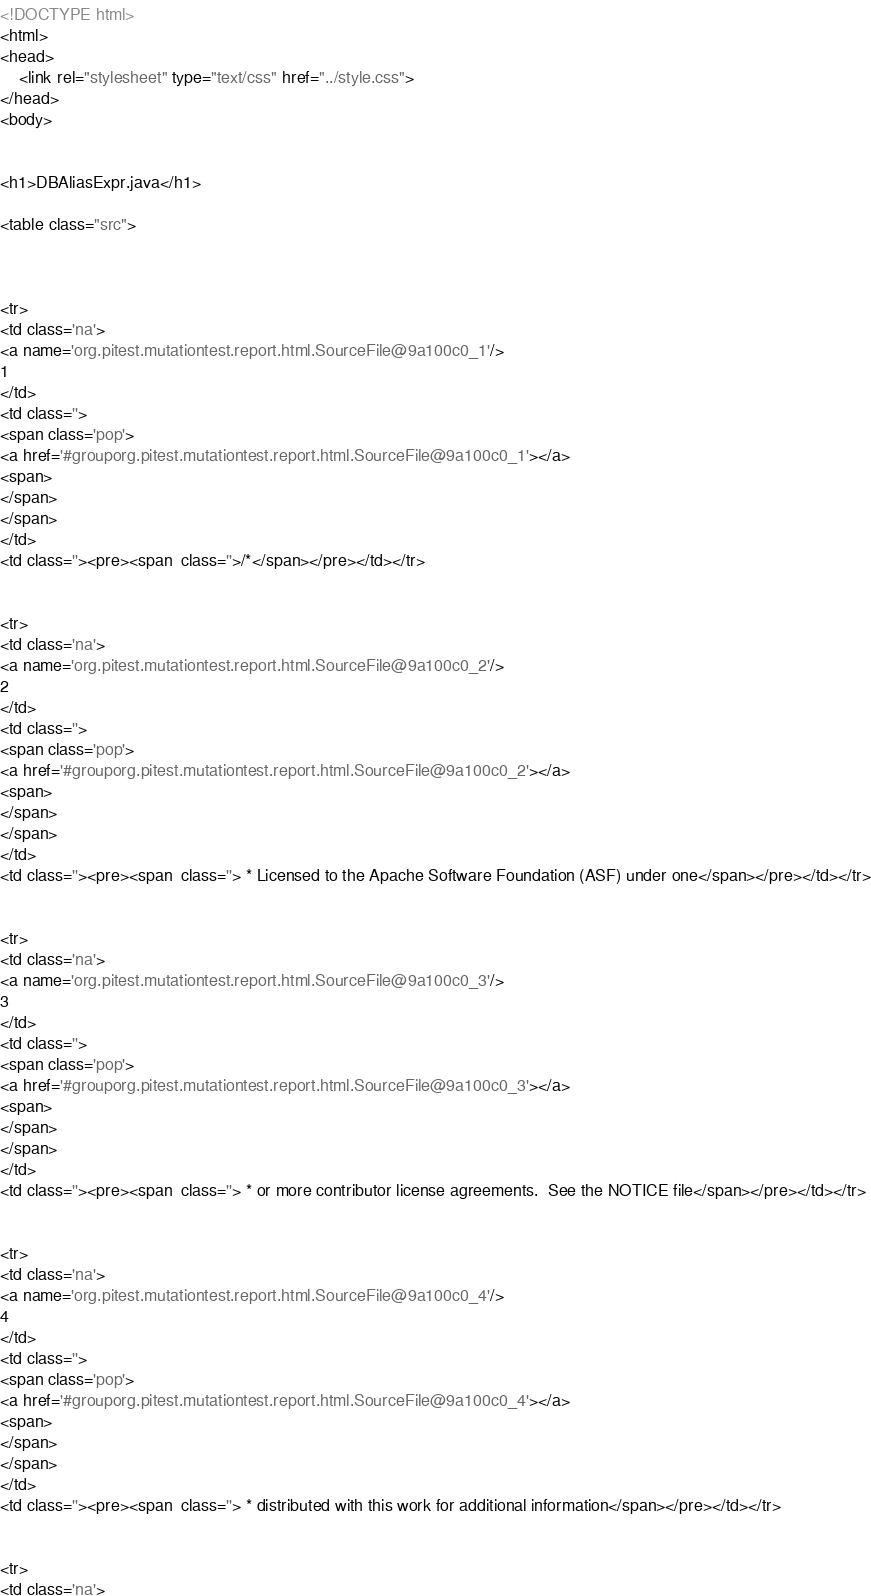Convert code to text. <code><loc_0><loc_0><loc_500><loc_500><_HTML_><!DOCTYPE html>
<html>
<head>
    <link rel="stylesheet" type="text/css" href="../style.css">
</head>
<body>


<h1>DBAliasExpr.java</h1>

<table class="src">



<tr>
<td class='na'>
<a name='org.pitest.mutationtest.report.html.SourceFile@9a100c0_1'/>
1
</td>
<td class=''>
<span class='pop'>
<a href='#grouporg.pitest.mutationtest.report.html.SourceFile@9a100c0_1'></a>
<span>
</span>
</span>
</td>
<td class=''><pre><span  class=''>/*</span></pre></td></tr>


<tr>
<td class='na'>
<a name='org.pitest.mutationtest.report.html.SourceFile@9a100c0_2'/>
2
</td>
<td class=''>
<span class='pop'>
<a href='#grouporg.pitest.mutationtest.report.html.SourceFile@9a100c0_2'></a>
<span>
</span>
</span>
</td>
<td class=''><pre><span  class=''> * Licensed to the Apache Software Foundation (ASF) under one</span></pre></td></tr>


<tr>
<td class='na'>
<a name='org.pitest.mutationtest.report.html.SourceFile@9a100c0_3'/>
3
</td>
<td class=''>
<span class='pop'>
<a href='#grouporg.pitest.mutationtest.report.html.SourceFile@9a100c0_3'></a>
<span>
</span>
</span>
</td>
<td class=''><pre><span  class=''> * or more contributor license agreements.  See the NOTICE file</span></pre></td></tr>


<tr>
<td class='na'>
<a name='org.pitest.mutationtest.report.html.SourceFile@9a100c0_4'/>
4
</td>
<td class=''>
<span class='pop'>
<a href='#grouporg.pitest.mutationtest.report.html.SourceFile@9a100c0_4'></a>
<span>
</span>
</span>
</td>
<td class=''><pre><span  class=''> * distributed with this work for additional information</span></pre></td></tr>


<tr>
<td class='na'></code> 